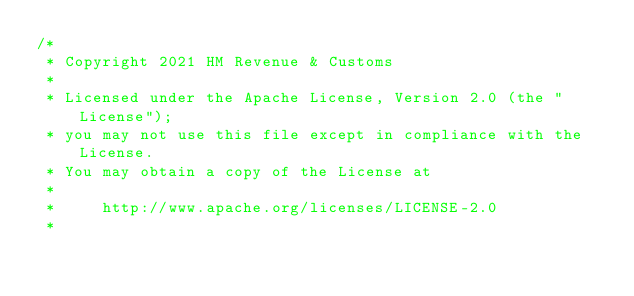<code> <loc_0><loc_0><loc_500><loc_500><_Kotlin_>/*
 * Copyright 2021 HM Revenue & Customs
 *
 * Licensed under the Apache License, Version 2.0 (the "License");
 * you may not use this file except in compliance with the License.
 * You may obtain a copy of the License at
 *
 *     http://www.apache.org/licenses/LICENSE-2.0
 *</code> 